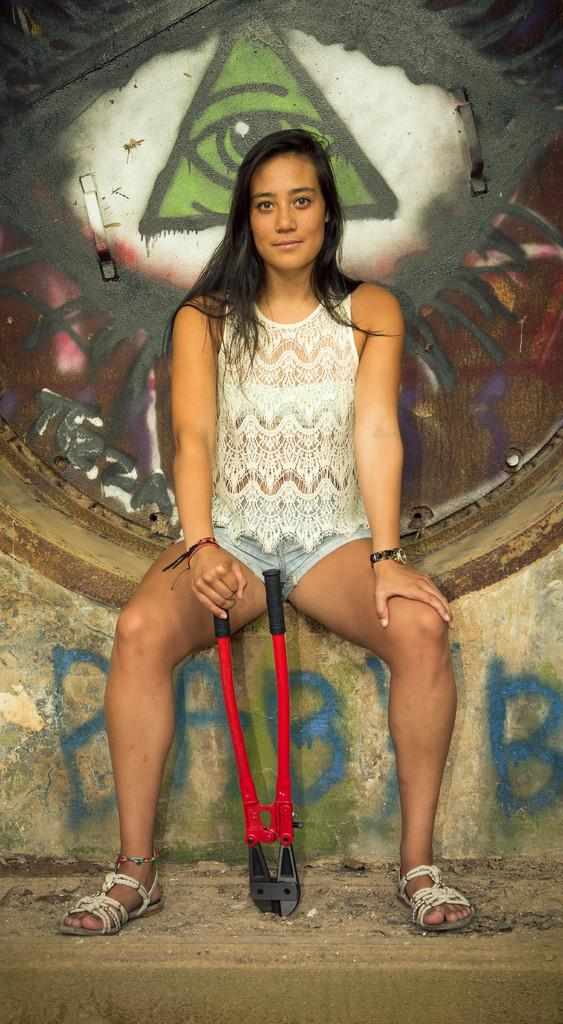What is the lady doing in the image? The lady is sitting in the image. What is the lady holding in her hand? The lady is holding a tool. What can be seen on the wall behind the lady? There is graffiti on the wall behind the lady. What type of clouds can be seen in the image? There are no clouds visible in the image; it is focused on the lady, her tool, and the graffiti on the wall. 